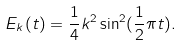Convert formula to latex. <formula><loc_0><loc_0><loc_500><loc_500>E _ { k } ( t ) = \frac { 1 } { 4 } k ^ { 2 } \sin ^ { 2 } ( \frac { 1 } { 2 } \pi t ) .</formula> 